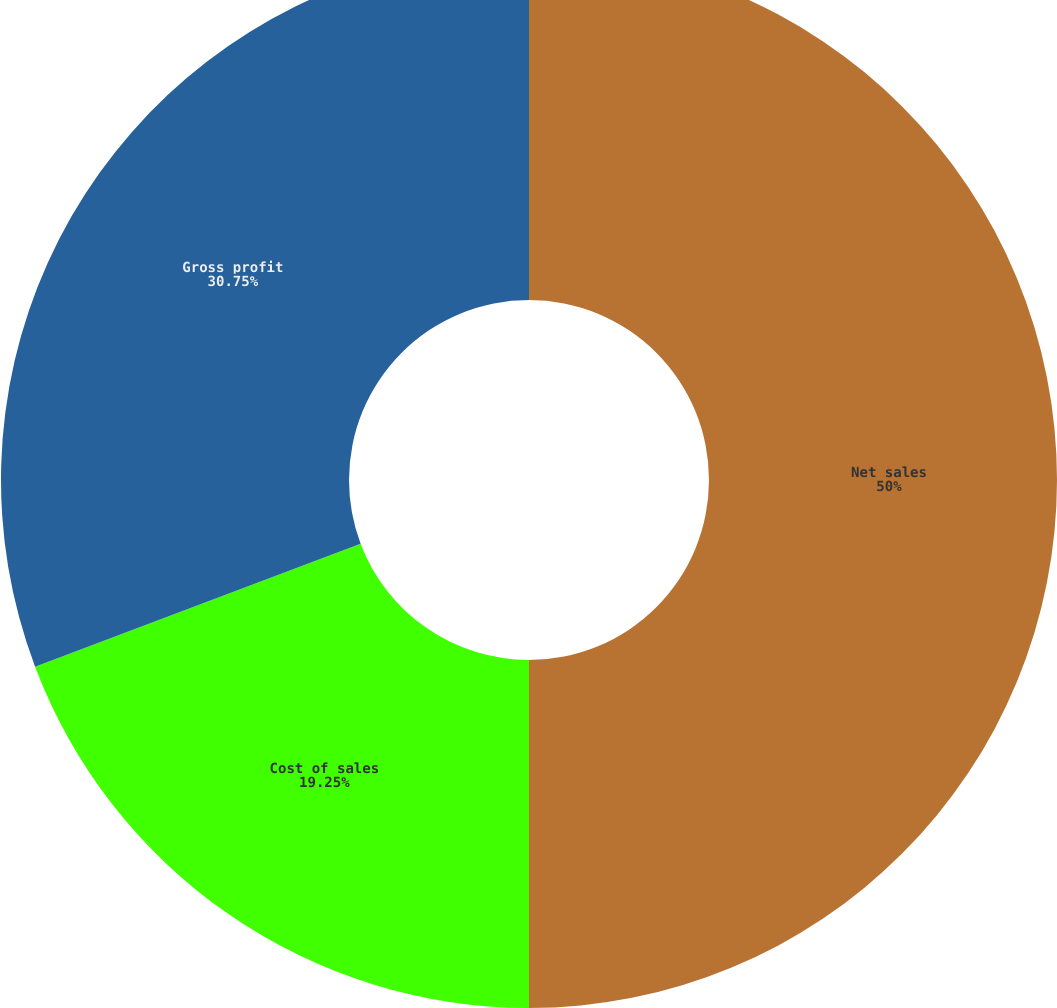Convert chart to OTSL. <chart><loc_0><loc_0><loc_500><loc_500><pie_chart><fcel>Net sales<fcel>Cost of sales<fcel>Gross profit<nl><fcel>50.0%<fcel>19.25%<fcel>30.75%<nl></chart> 